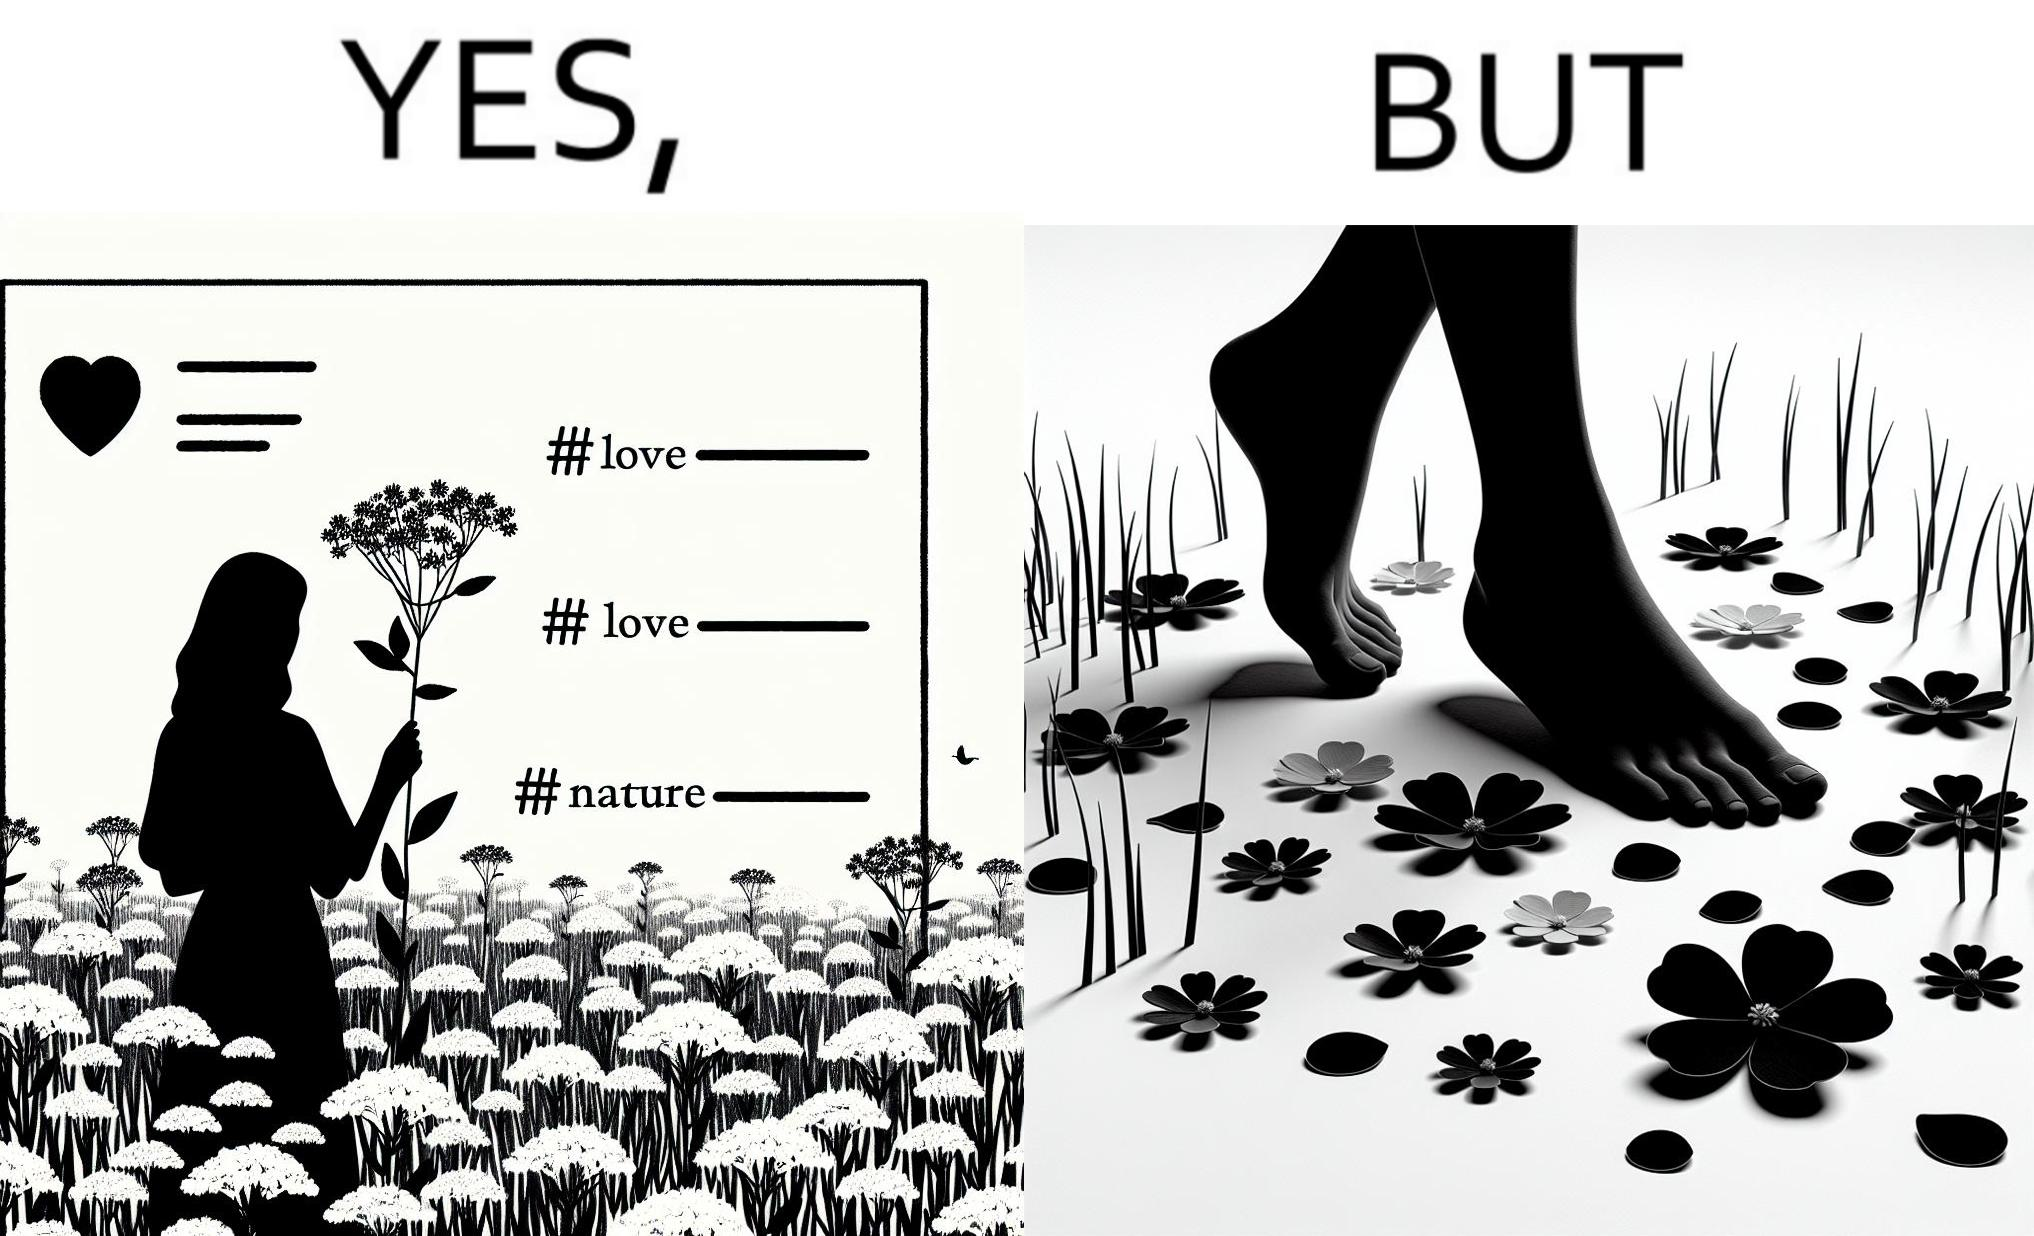What does this image depict? The image is ironical, as the social ,edia post shows the appreciation of nature, while an image of the feet on the ground stepping on the flower petals shows an unintentional disrespect of nature. 